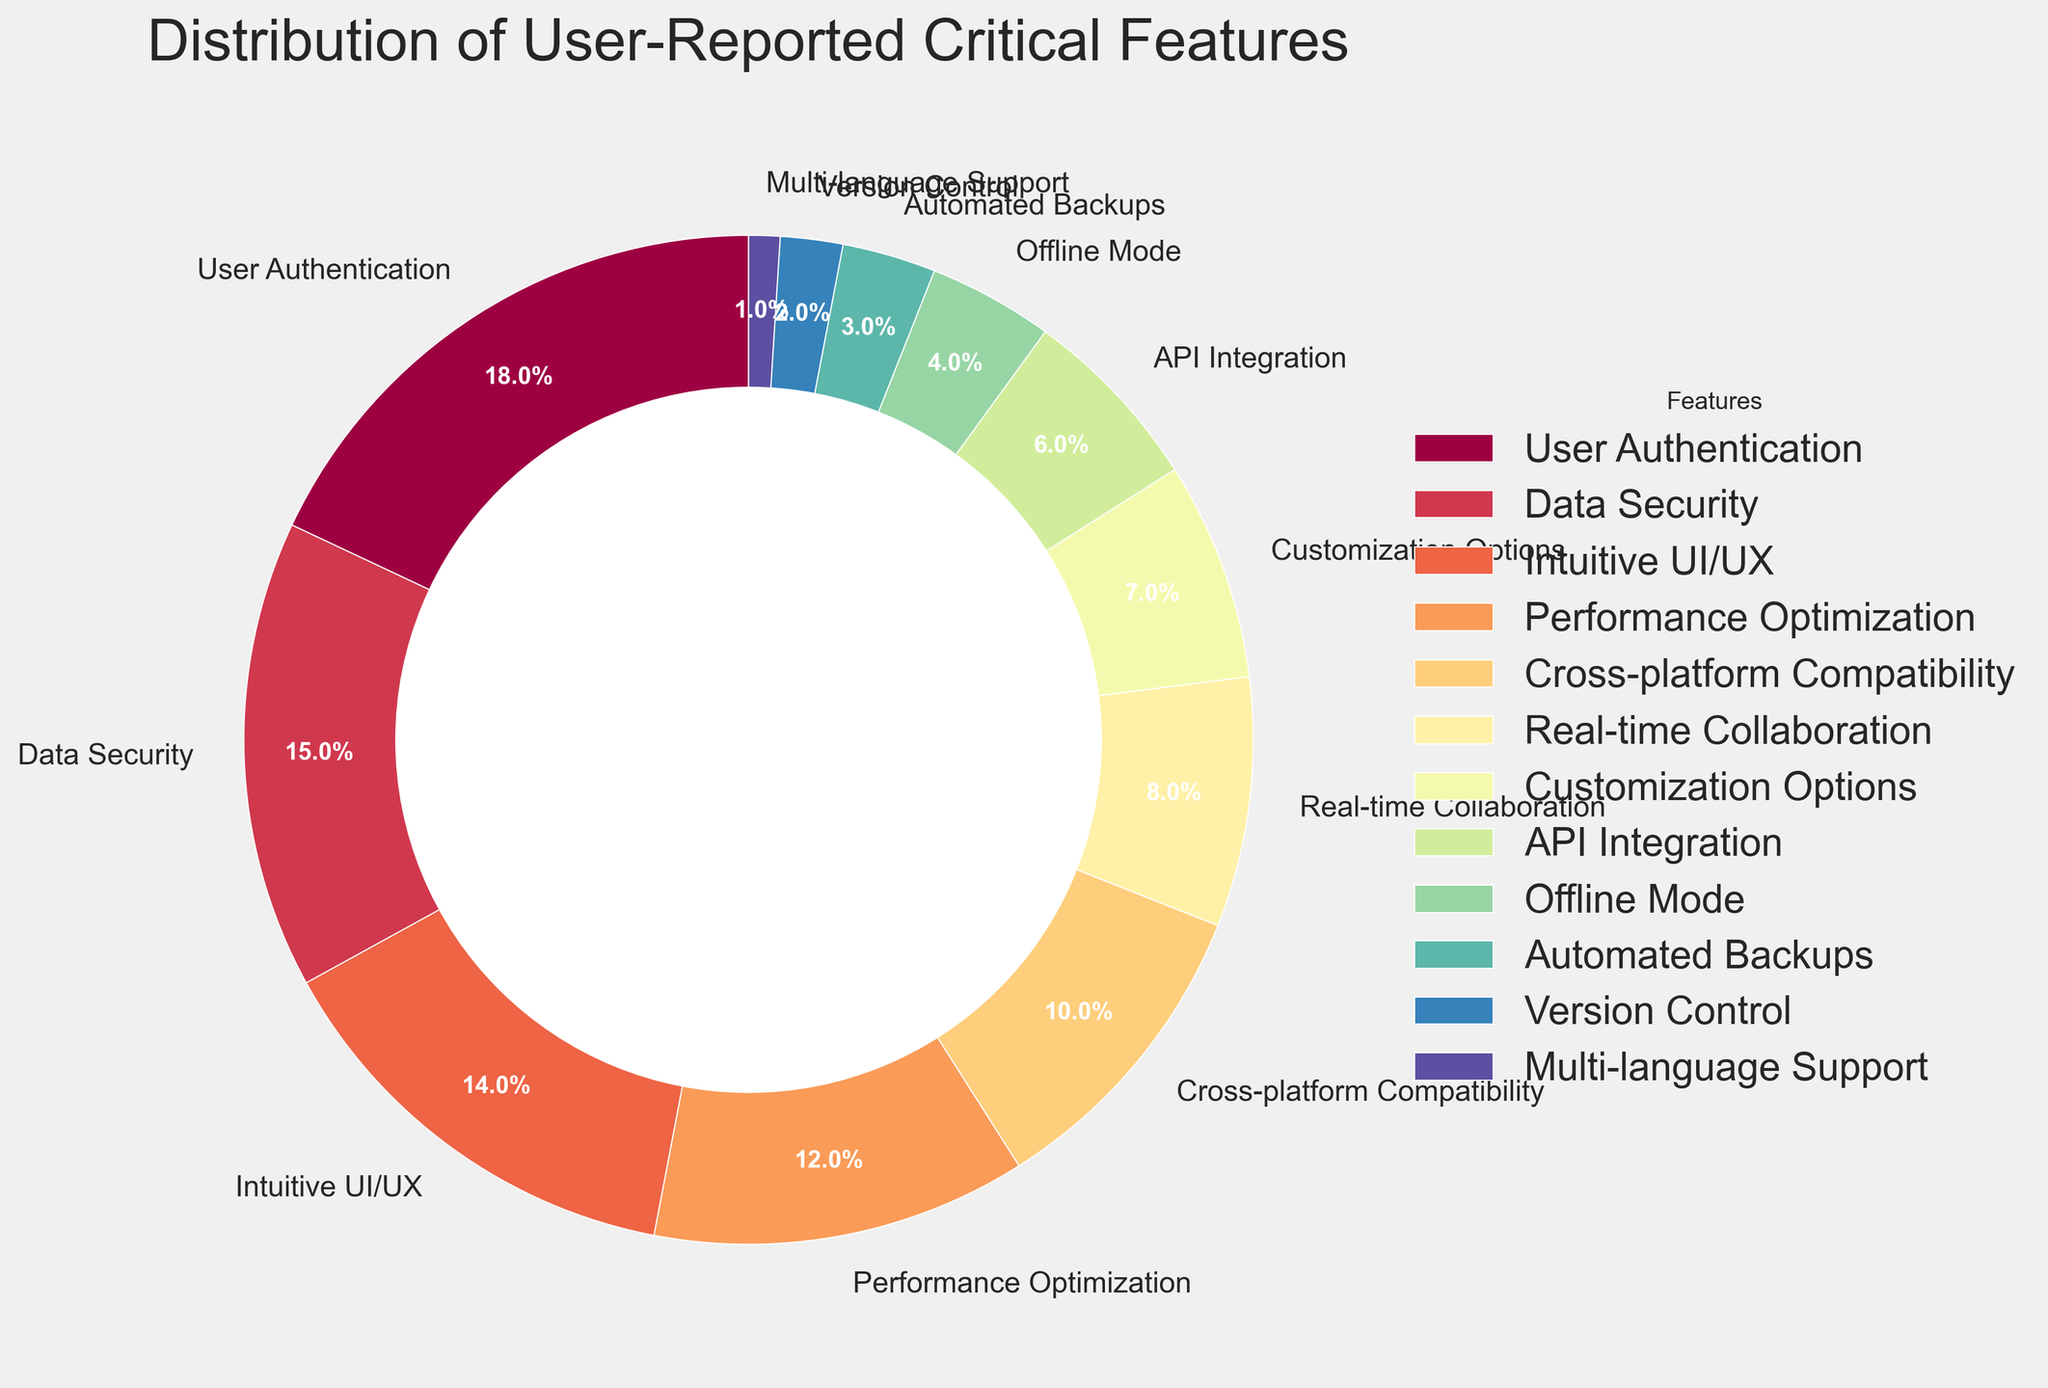What's the most reported critical feature? The most reported critical feature can be found by identifying the segment of the pie chart with the largest percentage. Here, the largest segment is labeled "User Authentication" with 18%.
Answer: User Authentication What is the combined percentage of user-reported features related to security (User Authentication and Data Security)? To find the combined percentage, sum the individual percentages for User Authentication (18%) and Data Security (15%). So, 18% + 15% = 33%.
Answer: 33% Which feature is less frequently reported: Real-time Collaboration or Offline Mode? Compare the percentages of Real-time Collaboration (8%) and Offline Mode (4%). Since 4% is less than 8%, Offline Mode is less frequently reported.
Answer: Offline Mode What's the difference in the reported percentages between Intuitive UI/UX and Multi-language Support? To find the difference, subtract the percentage for Multi-language Support (1%) from the percentage for Intuitive UI/UX (14%). So, 14% - 1% = 13%.
Answer: 13% Among the features with less than 10% reported, which one has the highest percentage? Among the features with less than 10% reported, the highest percentage is for Real-time Collaboration (8%).
Answer: Real-time Collaboration What is the sum of percentages of features with less than 5% reported? Sum the percentages of Automated Backups (3%), Version Control (2%), and Multi-language Support (1%). So, 3% + 2% + 1% = 6%.
Answer: 6% Is Performance Optimization more critical than Customization Options according to users? Compare the percentages of Performance Optimization (12%) and Customization Options (7%). Since 12% is greater than 7%, Performance Optimization is more critical.
Answer: Yes What's the average percentage for Cross-platform Compatibility and API Integration? To find the average percentage, sum the percentages of Cross-platform Compatibility (10%) and API Integration (6%) and divide by 2. So, (10% + 6%) / 2 = 8%.
Answer: 8% What color is associated with the largest segment? According to the color map used, the largest segment, which is "User Authentication," is associated with a color near the beginning of the color spectrum in the pie chart, which typically corresponds to red.
Answer: Red 